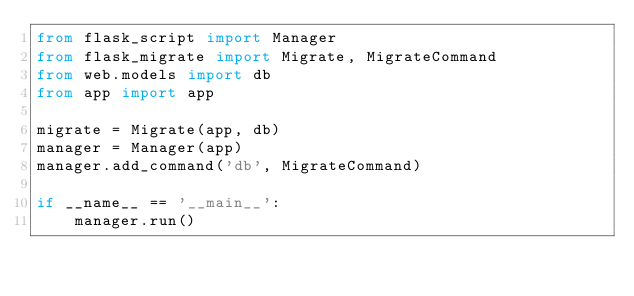<code> <loc_0><loc_0><loc_500><loc_500><_Python_>from flask_script import Manager
from flask_migrate import Migrate, MigrateCommand
from web.models import db
from app import app

migrate = Migrate(app, db)
manager = Manager(app)
manager.add_command('db', MigrateCommand)

if __name__ == '__main__':
    manager.run()

</code> 